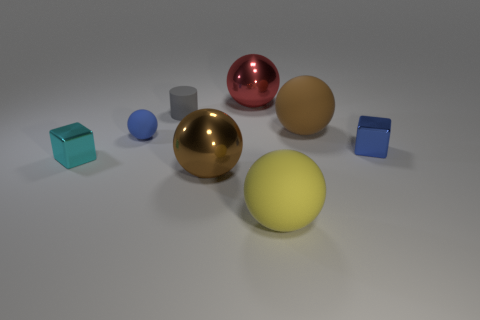How many other things are there of the same color as the tiny rubber sphere?
Offer a terse response. 1. There is a small cyan shiny block; are there any cyan things on the right side of it?
Keep it short and to the point. No. Is the large yellow sphere made of the same material as the small gray object?
Offer a terse response. Yes. There is a blue object that is the same size as the blue ball; what is its material?
Your answer should be very brief. Metal. How many objects are either tiny cubes right of the cyan block or green rubber cubes?
Your response must be concise. 1. Is the number of tiny cyan shiny objects in front of the cyan cube the same as the number of small metal things?
Your answer should be compact. No. Does the cylinder have the same color as the tiny ball?
Your answer should be very brief. No. The large sphere that is in front of the blue ball and on the right side of the brown metallic object is what color?
Give a very brief answer. Yellow. How many cubes are either big things or tiny gray rubber things?
Provide a succinct answer. 0. Are there fewer tiny spheres that are to the right of the brown metallic ball than small objects?
Offer a terse response. Yes. 